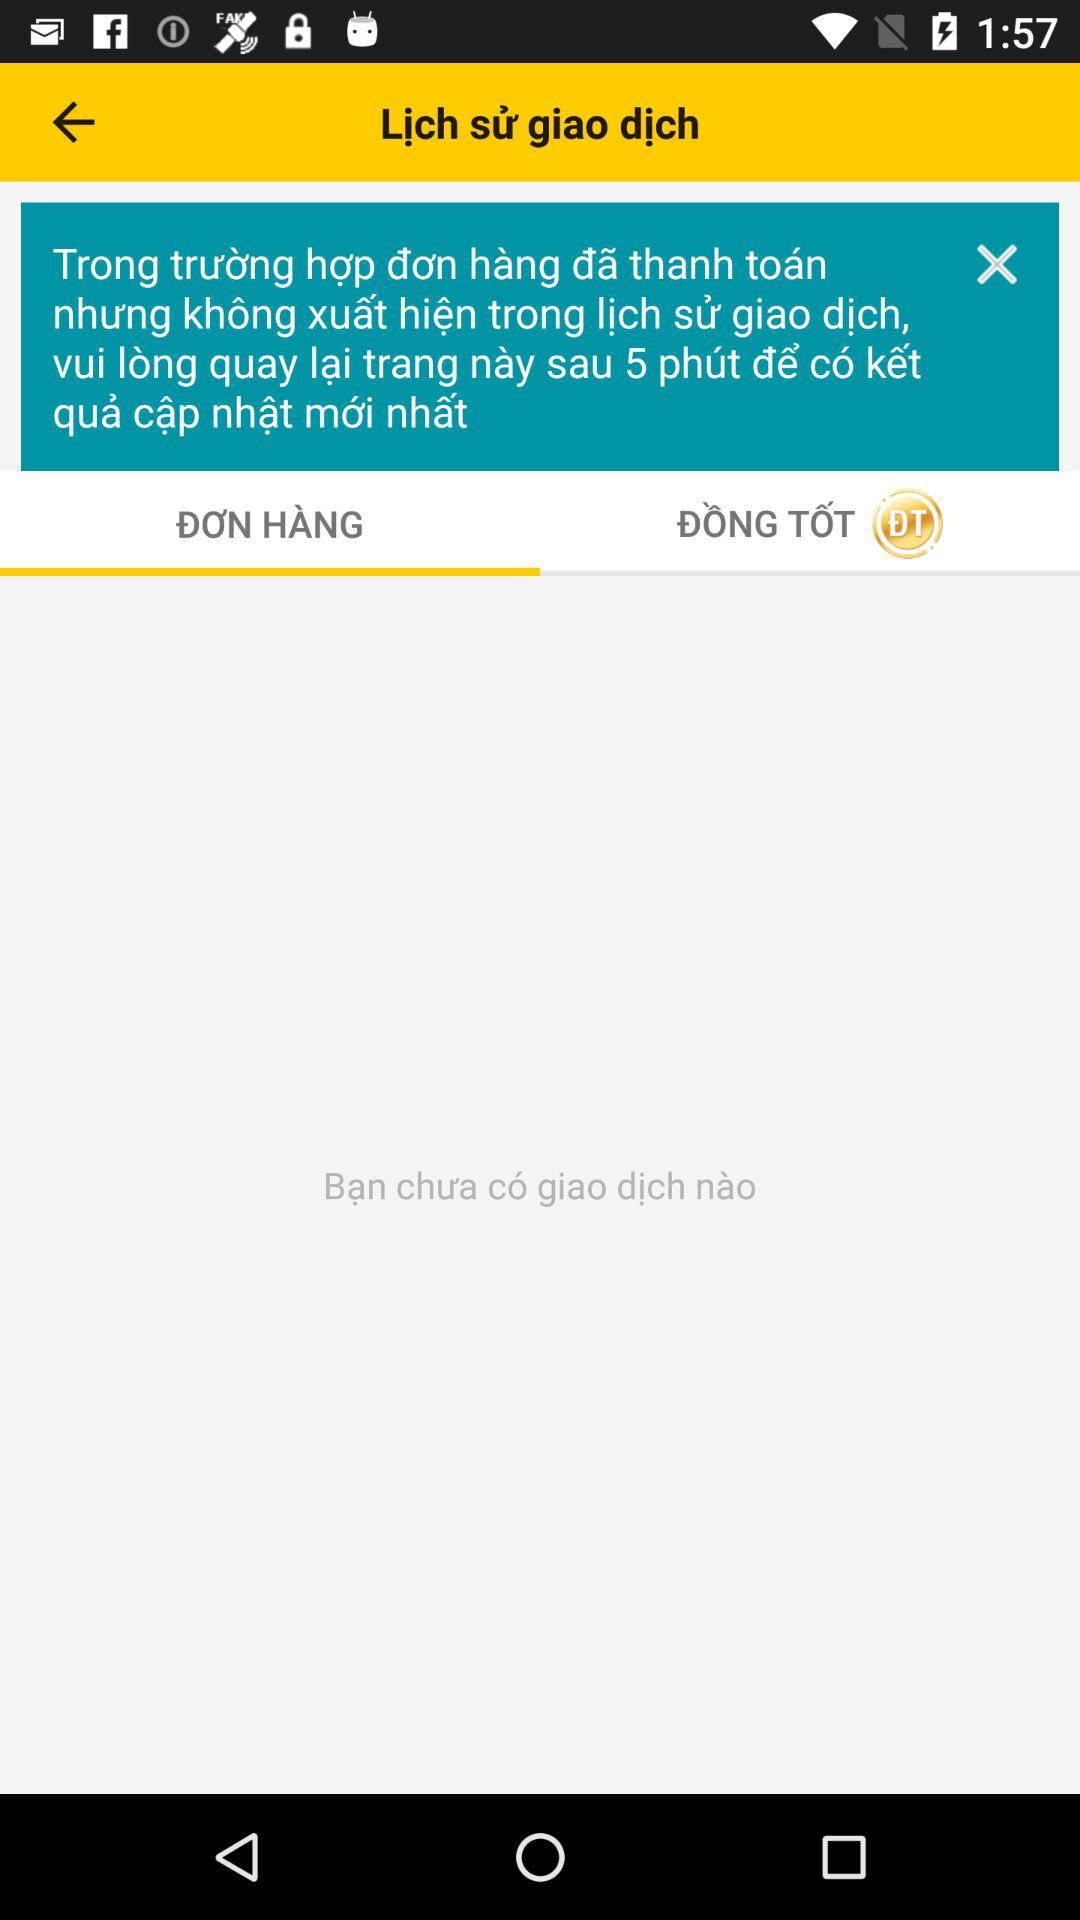How many transactions do I have?
Answer the question using a single word or phrase. 0 